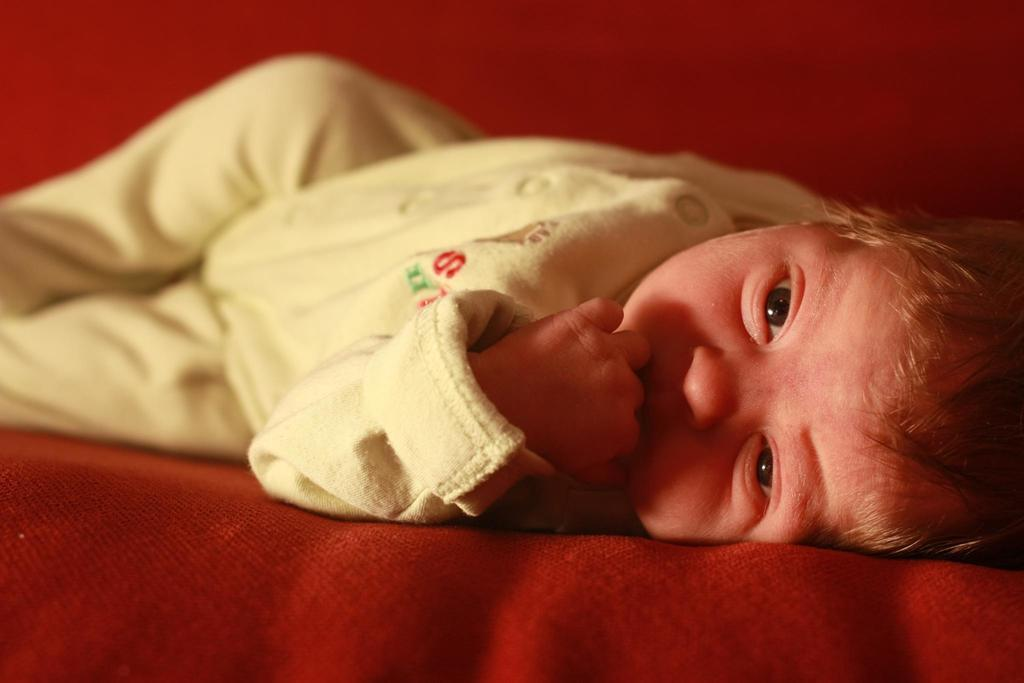What is the main subject of the picture? The main subject of the picture is a baby. Where is the baby located in the image? The baby is laying on a bed. What is the baby wearing in the picture? The baby is wearing a cream-colored dress. Can you see any coastline in the picture? There is no coastline visible in the picture; it features a baby laying on a bed. Is there a woman interacting with the baby in the picture? The provided facts do not mention a woman in the image, so we cannot confirm her presence. 